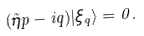Convert formula to latex. <formula><loc_0><loc_0><loc_500><loc_500>( \tilde { \eta } p - i q ) | \xi _ { q } \rangle = 0 .</formula> 